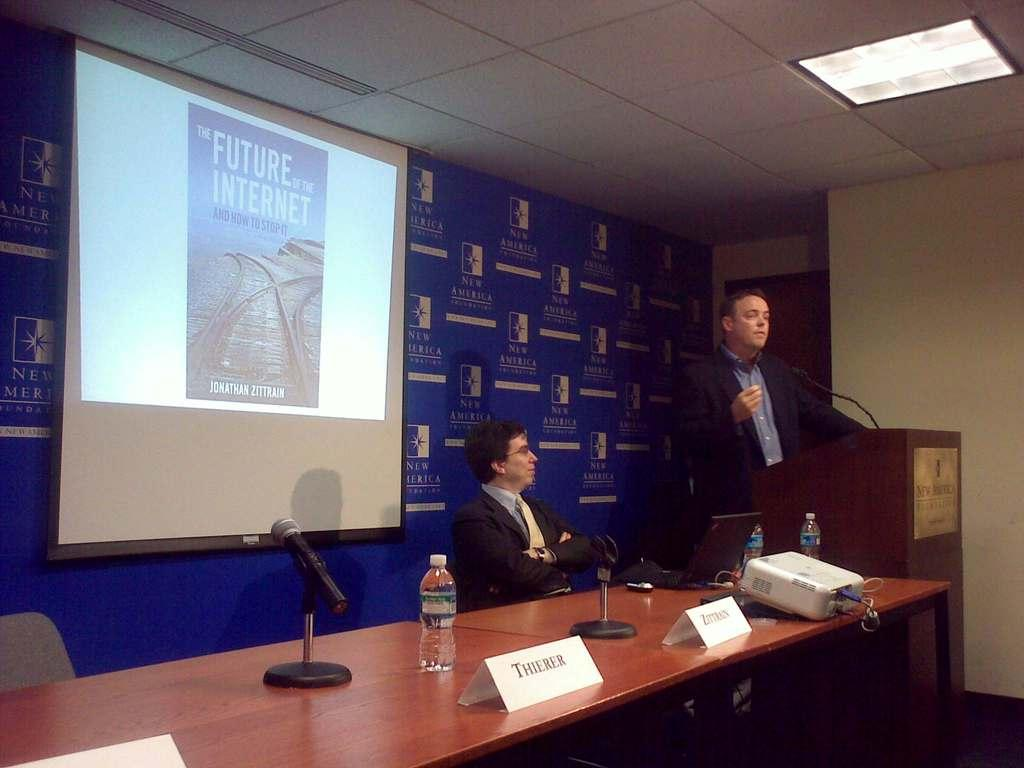<image>
Relay a brief, clear account of the picture shown. a man at a meeting with the future of the internet behind him 